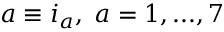<formula> <loc_0><loc_0><loc_500><loc_500>a \equiv i _ { a } , \, a = 1 , \dots , 7</formula> 